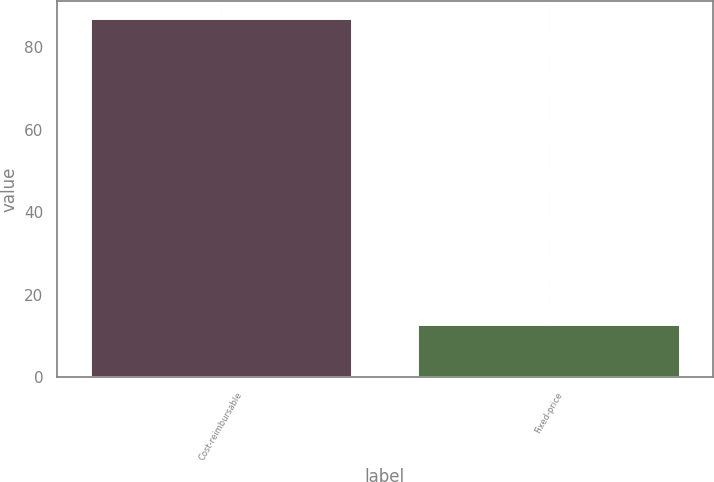<chart> <loc_0><loc_0><loc_500><loc_500><bar_chart><fcel>Cost-reimbursable<fcel>Fixed-price<nl><fcel>87<fcel>13<nl></chart> 